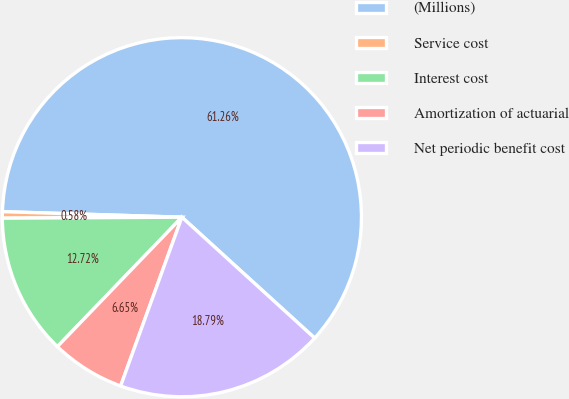<chart> <loc_0><loc_0><loc_500><loc_500><pie_chart><fcel>(Millions)<fcel>Service cost<fcel>Interest cost<fcel>Amortization of actuarial<fcel>Net periodic benefit cost<nl><fcel>61.27%<fcel>0.58%<fcel>12.72%<fcel>6.65%<fcel>18.79%<nl></chart> 